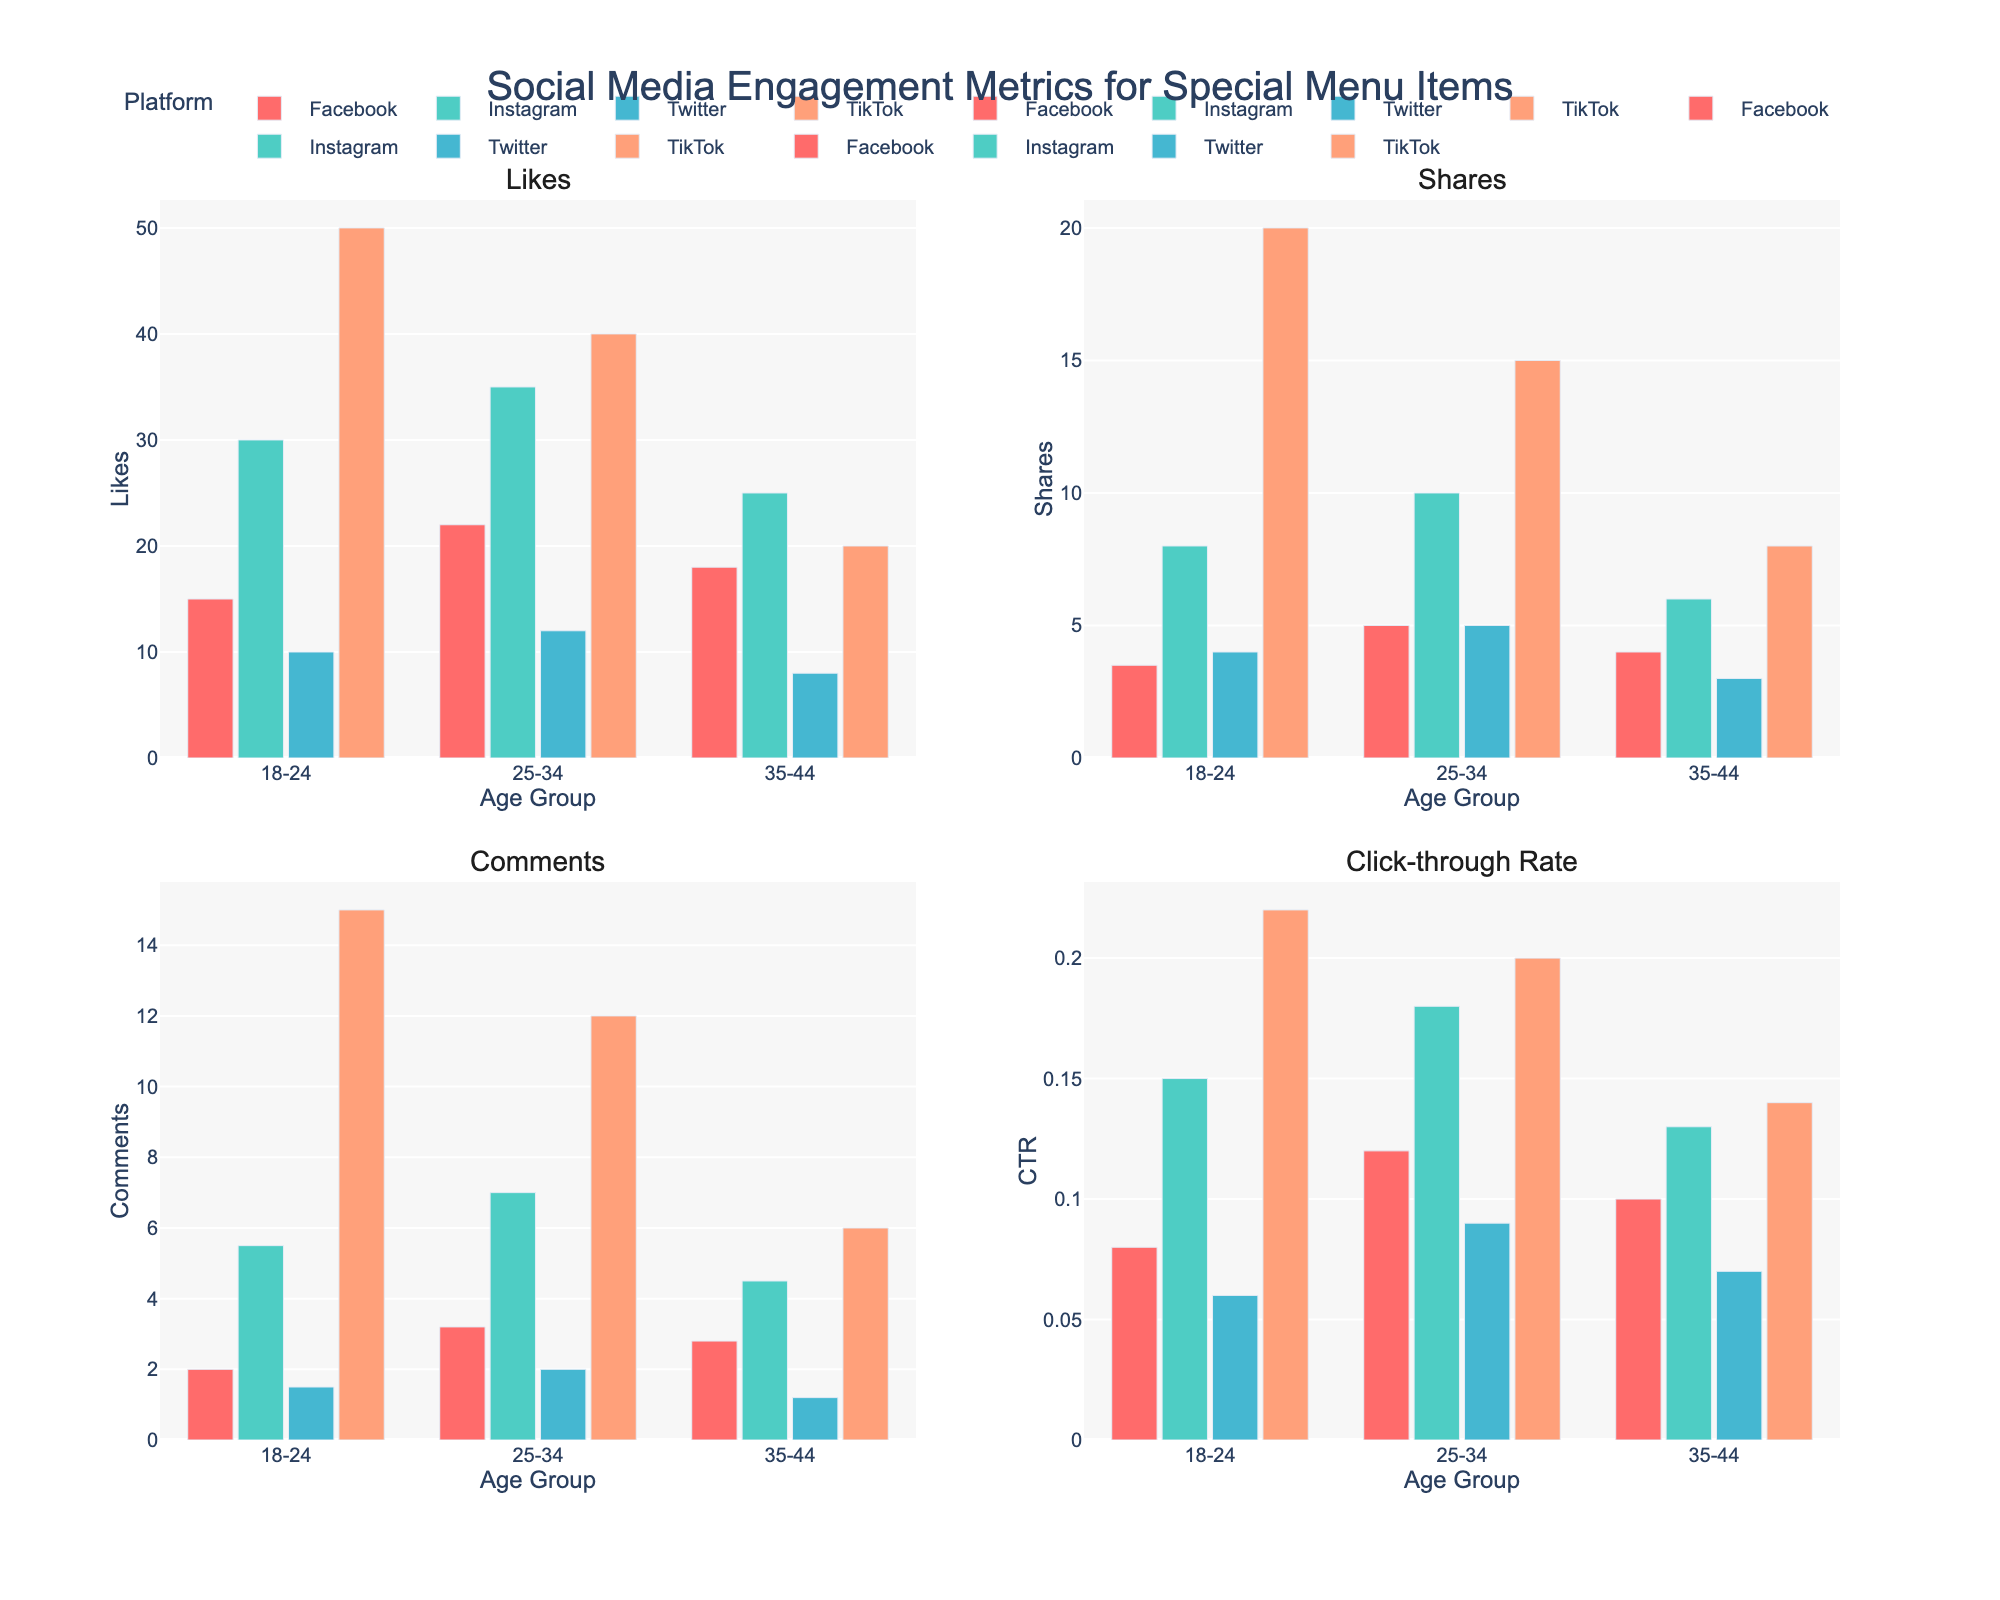How many different age groups are shown in the figure? The figure shows four bar charts, each divided by age group, indicated on the x-axes. Each plot lists three age groups: 18-24, 25-34, and 35-44.
Answer: 3 Which platform has the highest number of Likes for the 25-34 age group? In the subplot for Likes, the bar representing Instagram for 25-34 stands the tallest. Facebook and TikTok have lower bars.
Answer: Instagram What is the total number of Shares on TikTok across all age groups? In the subplot for Shares, sum the heights of TikTok's bars in the thousands: 20K + 15K + 8K = 43K.
Answer: 43,000 How does the Click-through Rate (CTR) for the 18-24 age group on Twitter compare to Facebook? In the subplot for CTR, compare the bars for 18-24. Twitter's CTR is 0.06, and Facebook's CTR is 0.08. Twitter's CTR is lower.
Answer: Twitter CTR is lower Which demographic shows the highest engagement in terms of Comments on Instagram? In the subplot for Comments, look at the height of Instagram's bars. The tallest bar for Instagram is for the 25-34 age group.
Answer: 25-34 What is the difference in the number of Likes between the 35-44 and 18-24 age groups on Facebook? Look at the Likes subplot. Facebook for 35-44 is 18K and for 18-24 is 15K. The difference is 18K - 15K = 3K.
Answer: 3,000 Summarize the Click-through Rates (CTR) for the 25-34 age group across all platforms. Check the CTR subplot and note values for 25-34: Facebook (0.12), Instagram (0.18), Twitter (0.09), and TikTok (0.20). These rates are 0.12, 0.18, 0.09, and 0.20 respectively.
Answer: 0.12, 0.18, 0.09, 0.20 For the Shares metric, which platform shows the least engagement for the 35-44 age group? Look at the Shares subplot for the 35-44 age group. Twitter's bar is the shortest, indicating the least engagement.
Answer: Twitter Calculate the average Click-through Rate (CTR) for the 18-24 age group across all platforms. Add the CTRs for 18-24: Facebook (0.08), Instagram (0.15), Twitter (0.06), and TikTok (0.22). Then, divide by 4: (0.08 + 0.15 + 0.06 + 0.22) / 4 = 0.1275.
Answer: 0.1275 Which platform has the lowest number of Comments for the 35-44 age group? Refer to the Comments subplot for 35-44. Twitter's bar is the shortest.
Answer: Twitter 